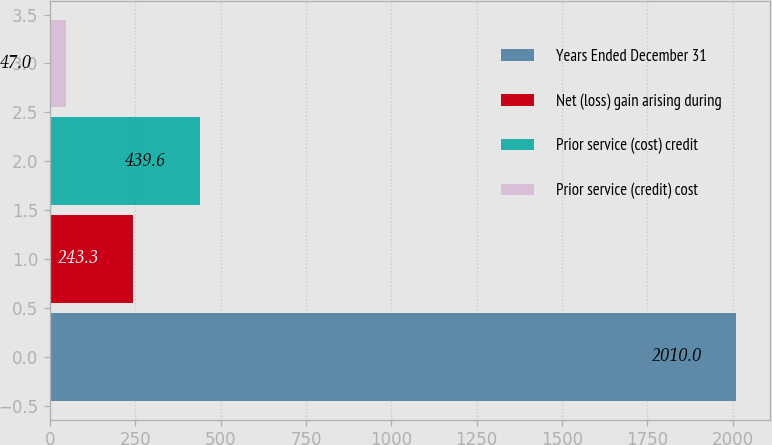Convert chart to OTSL. <chart><loc_0><loc_0><loc_500><loc_500><bar_chart><fcel>Years Ended December 31<fcel>Net (loss) gain arising during<fcel>Prior service (cost) credit<fcel>Prior service (credit) cost<nl><fcel>2010<fcel>243.3<fcel>439.6<fcel>47<nl></chart> 